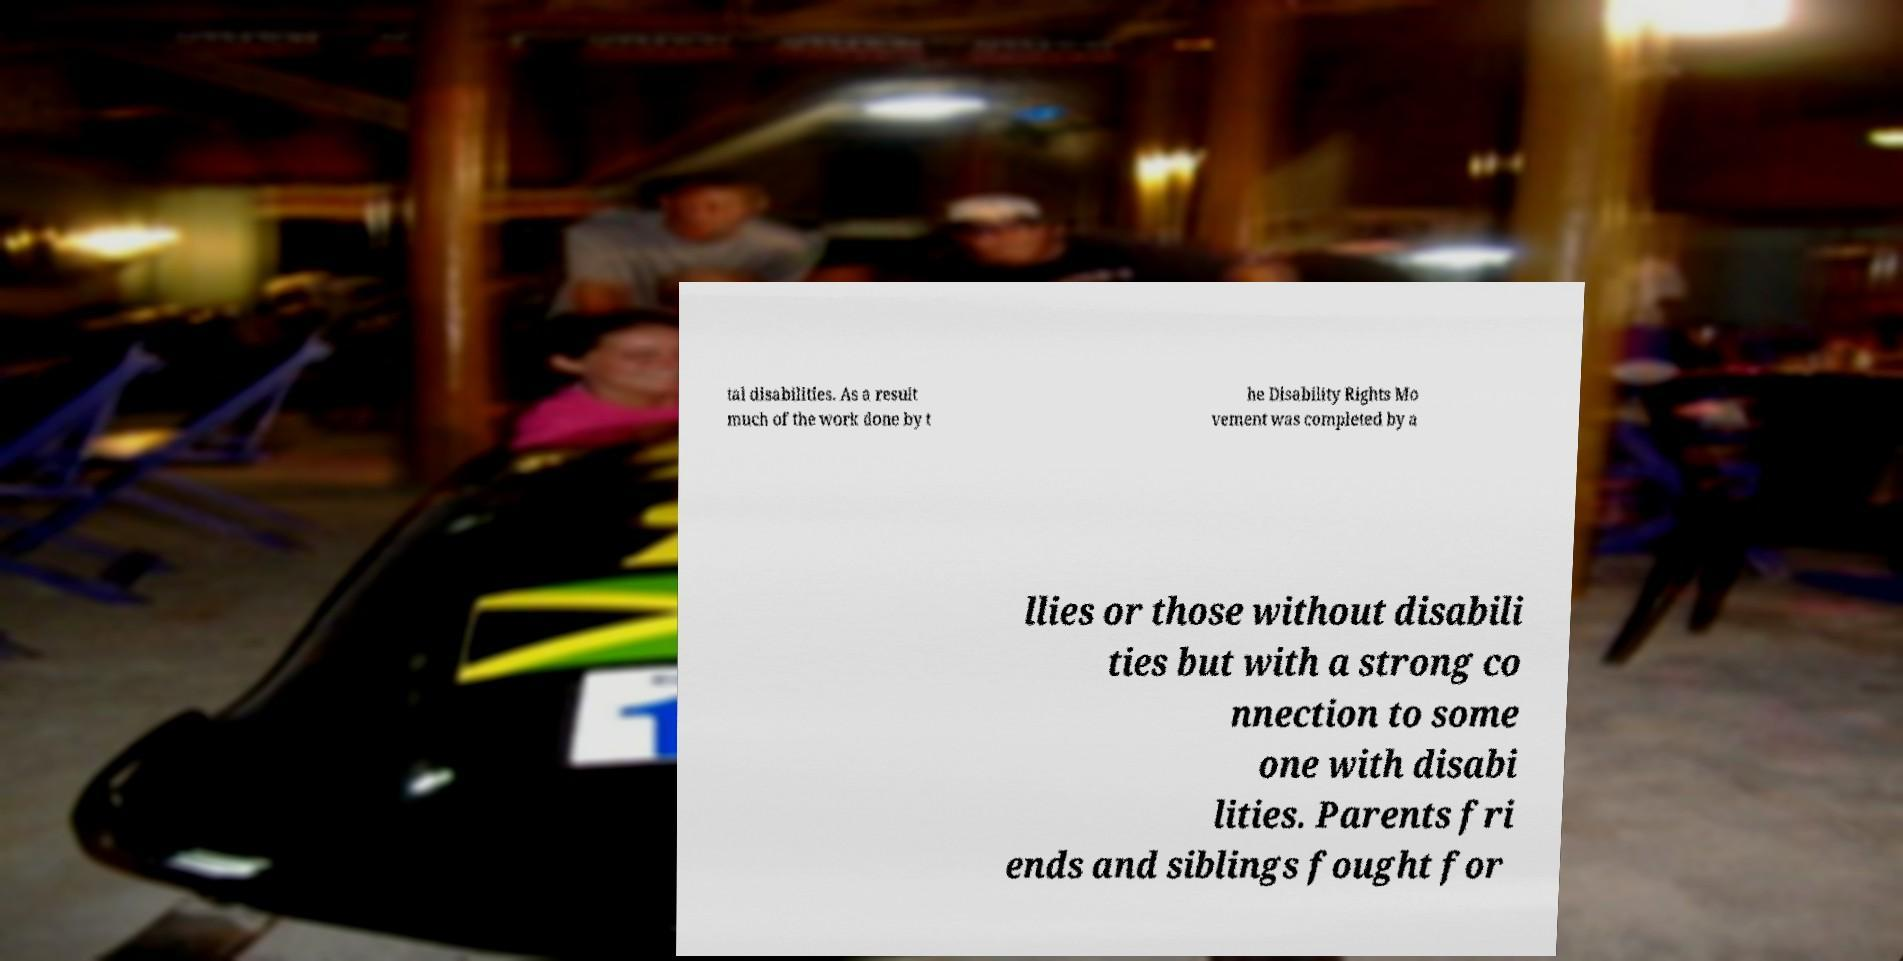Could you assist in decoding the text presented in this image and type it out clearly? tal disabilities. As a result much of the work done by t he Disability Rights Mo vement was completed by a llies or those without disabili ties but with a strong co nnection to some one with disabi lities. Parents fri ends and siblings fought for 